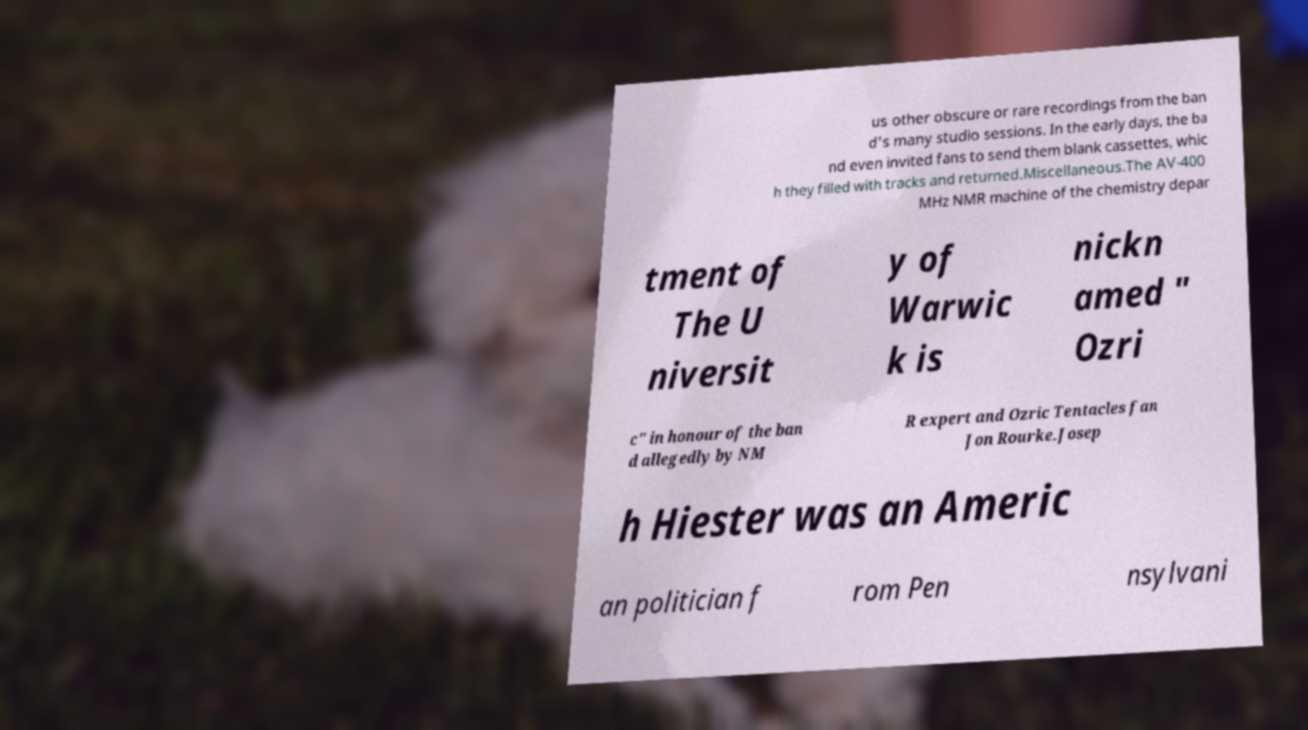I need the written content from this picture converted into text. Can you do that? us other obscure or rare recordings from the ban d's many studio sessions. In the early days, the ba nd even invited fans to send them blank cassettes, whic h they filled with tracks and returned.Miscellaneous.The AV-400 MHz NMR machine of the chemistry depar tment of The U niversit y of Warwic k is nickn amed " Ozri c" in honour of the ban d allegedly by NM R expert and Ozric Tentacles fan Jon Rourke.Josep h Hiester was an Americ an politician f rom Pen nsylvani 